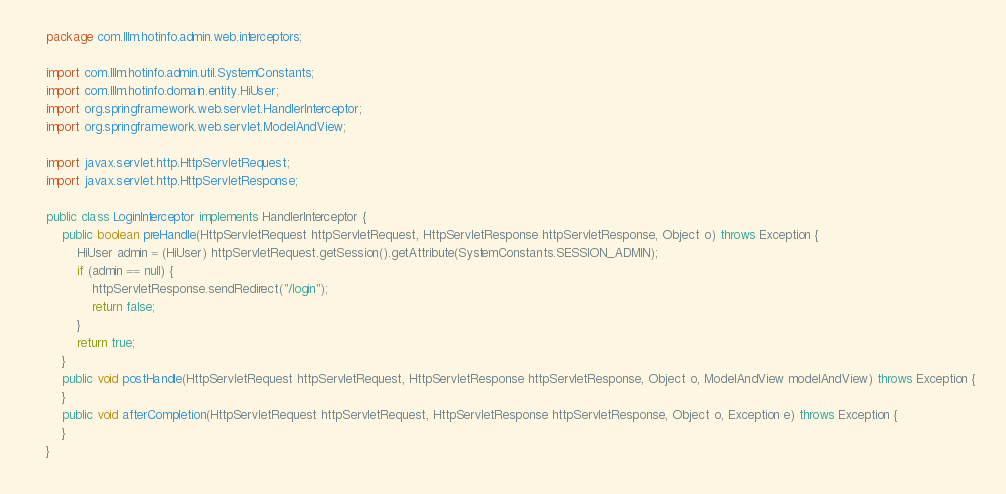Convert code to text. <code><loc_0><loc_0><loc_500><loc_500><_Java_>    package com.lllm.hotinfo.admin.web.interceptors;

    import com.lllm.hotinfo.admin.util.SystemConstants;
    import com.lllm.hotinfo.domain.entity.HiUser;
    import org.springframework.web.servlet.HandlerInterceptor;
    import org.springframework.web.servlet.ModelAndView;

    import javax.servlet.http.HttpServletRequest;
    import javax.servlet.http.HttpServletResponse;

    public class LoginInterceptor implements HandlerInterceptor {
        public boolean preHandle(HttpServletRequest httpServletRequest, HttpServletResponse httpServletResponse, Object o) throws Exception {
            HiUser admin = (HiUser) httpServletRequest.getSession().getAttribute(SystemConstants.SESSION_ADMIN);
            if (admin == null) {
                httpServletResponse.sendRedirect("/login");
                return false;
            }
            return true;
        }
        public void postHandle(HttpServletRequest httpServletRequest, HttpServletResponse httpServletResponse, Object o, ModelAndView modelAndView) throws Exception {
        }
        public void afterCompletion(HttpServletRequest httpServletRequest, HttpServletResponse httpServletResponse, Object o, Exception e) throws Exception {
        }
    }
</code> 